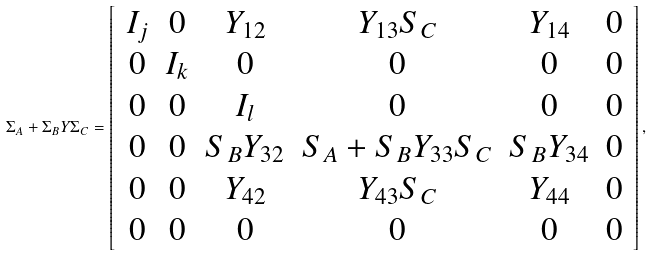<formula> <loc_0><loc_0><loc_500><loc_500>\Sigma _ { A } + \Sigma _ { B } Y \Sigma _ { C } = \left [ \, \begin{array} { c c c c c c } I _ { j } & 0 & Y _ { 1 2 } & Y _ { 1 3 } S _ { C } & Y _ { 1 4 } & 0 \\ 0 & I _ { k } & 0 & 0 & 0 & 0 \\ 0 & 0 & I _ { l } & 0 & 0 & 0 \\ 0 & 0 & S _ { B } Y _ { 3 2 } & S _ { A } + S _ { B } Y _ { 3 3 } S _ { C } & S _ { B } Y _ { 3 4 } & 0 \\ 0 & 0 & Y _ { 4 2 } & Y _ { 4 3 } S _ { C } & Y _ { 4 4 } & 0 \\ 0 & 0 & 0 & 0 & 0 & 0 \end{array} \, \right ] ,</formula> 